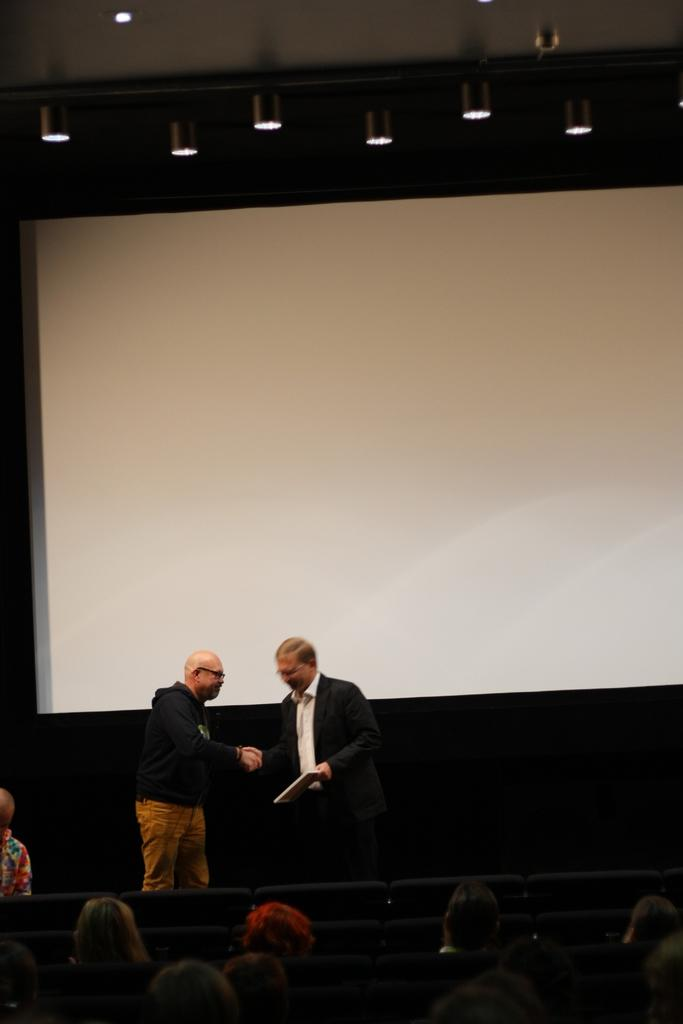How many people are in the image? There is a group of people in the image. What is one person in the group doing? One person is holding an object. What can be seen in the background of the image? There is a projector screen and lights visible in the background of the image. What type of toy is being discussed by the group in the image? There is no indication in the image that the group is discussing a toy or any specific topic. 